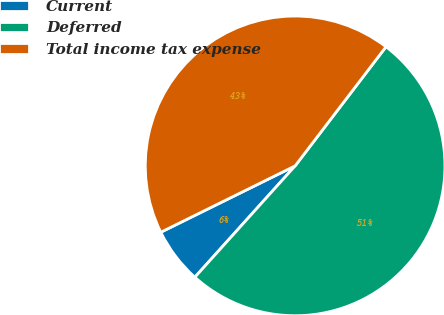<chart> <loc_0><loc_0><loc_500><loc_500><pie_chart><fcel>Current<fcel>Deferred<fcel>Total income tax expense<nl><fcel>6.03%<fcel>51.29%<fcel>42.67%<nl></chart> 